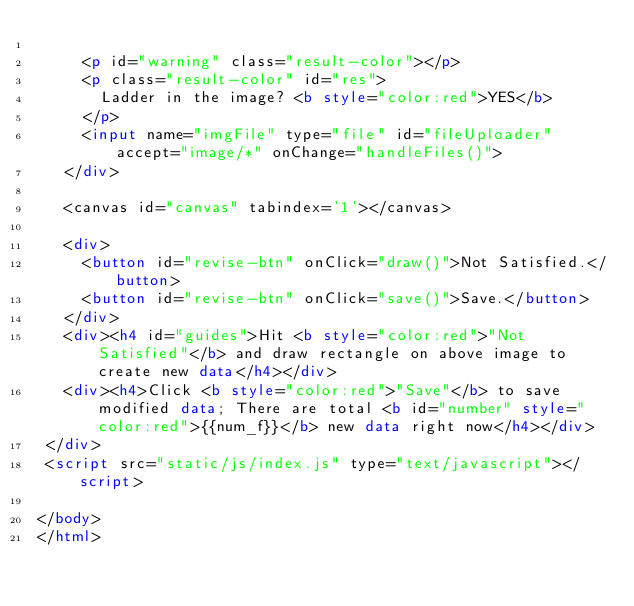<code> <loc_0><loc_0><loc_500><loc_500><_HTML_>
     <p id="warning" class="result-color"></p>
     <p class="result-color" id="res">
       Ladder in the image? <b style="color:red">YES</b>
     </p>
     <input name="imgFile" type="file" id="fileUploader" accept="image/*" onChange="handleFiles()">
   </div>

   <canvas id="canvas" tabindex='1'></canvas>

   <div>
     <button id="revise-btn" onClick="draw()">Not Satisfied.</button>
     <button id="revise-btn" onClick="save()">Save.</button>
   </div>
   <div><h4 id="guides">Hit <b style="color:red">"Not Satisfied"</b> and draw rectangle on above image to create new data</h4></div>
   <div><h4>Click <b style="color:red">"Save"</b> to save modified data; There are total <b id="number" style="color:red">{{num_f}}</b> new data right now</h4></div>
 </div>
 <script src="static/js/index.js" type="text/javascript"></script>

</body>
</html>
</code> 